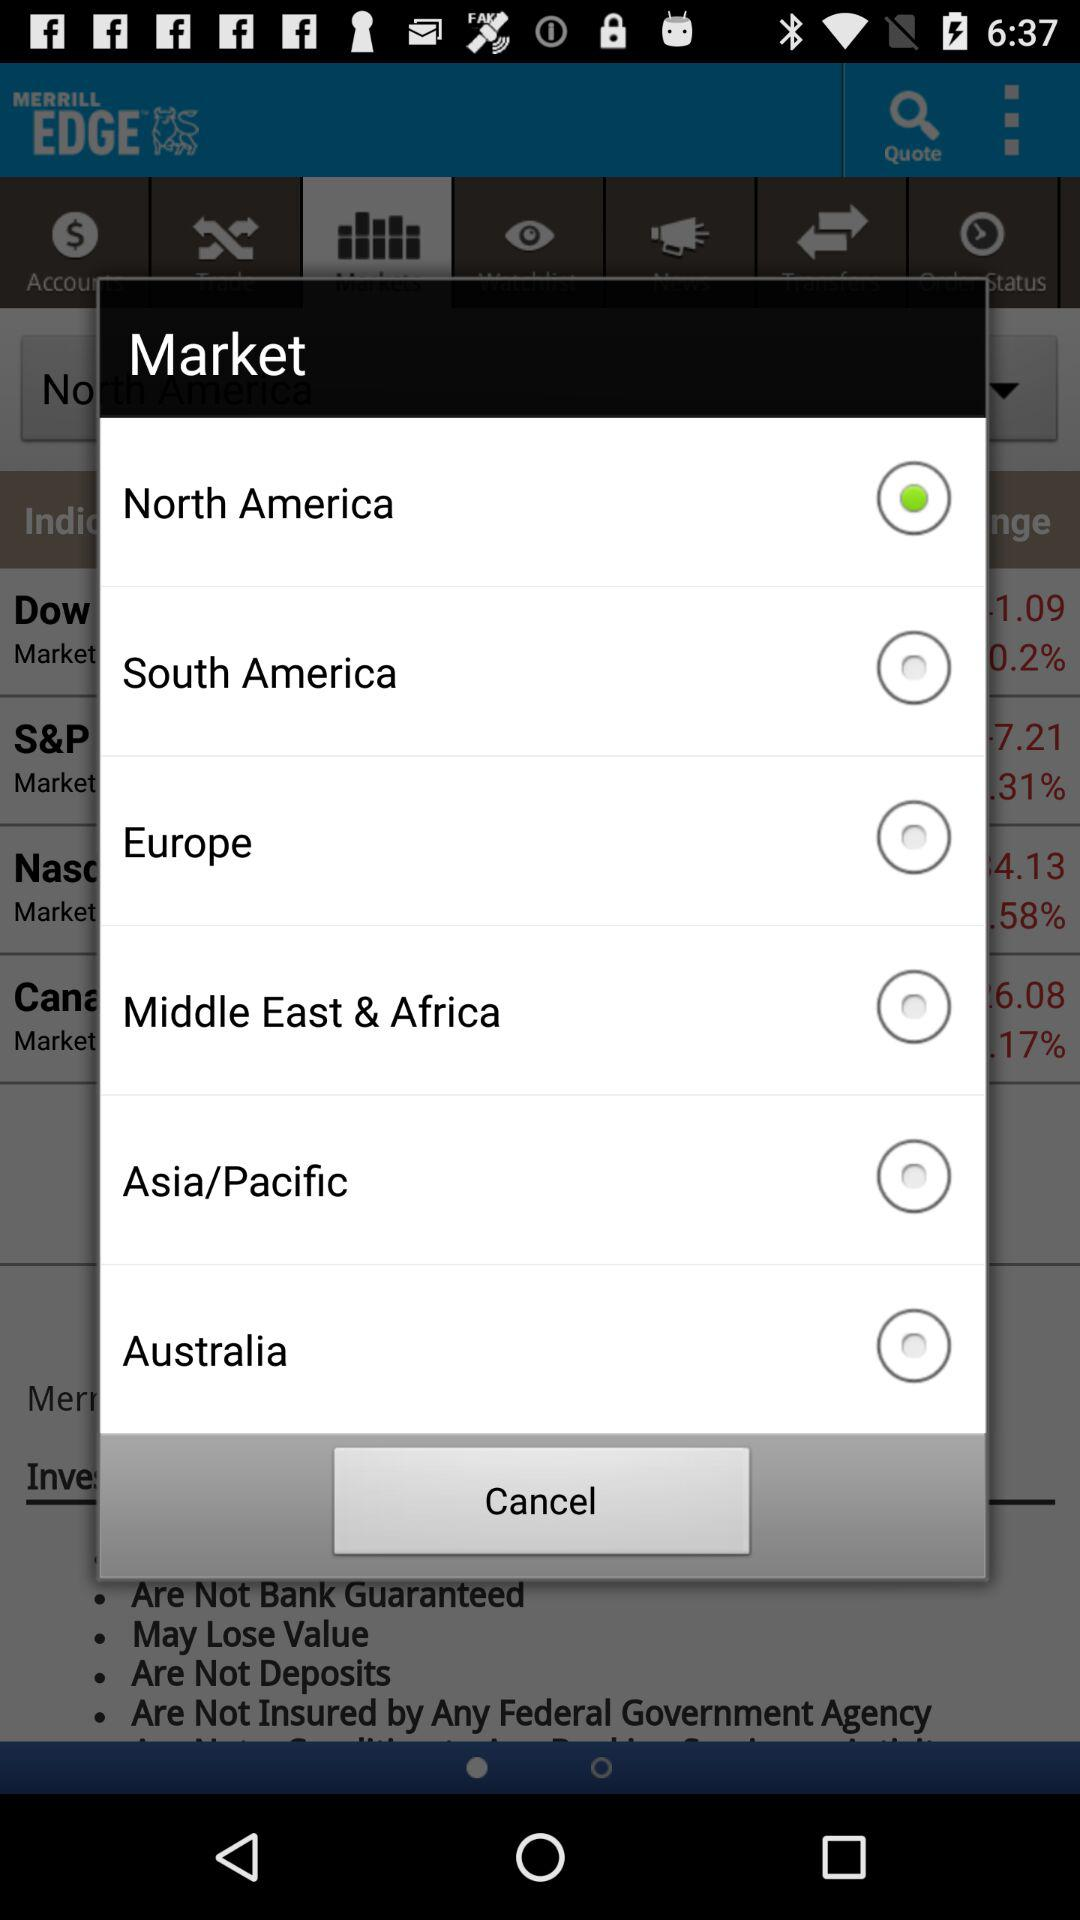Which country is selected in "Market"? The selected country is North America. 